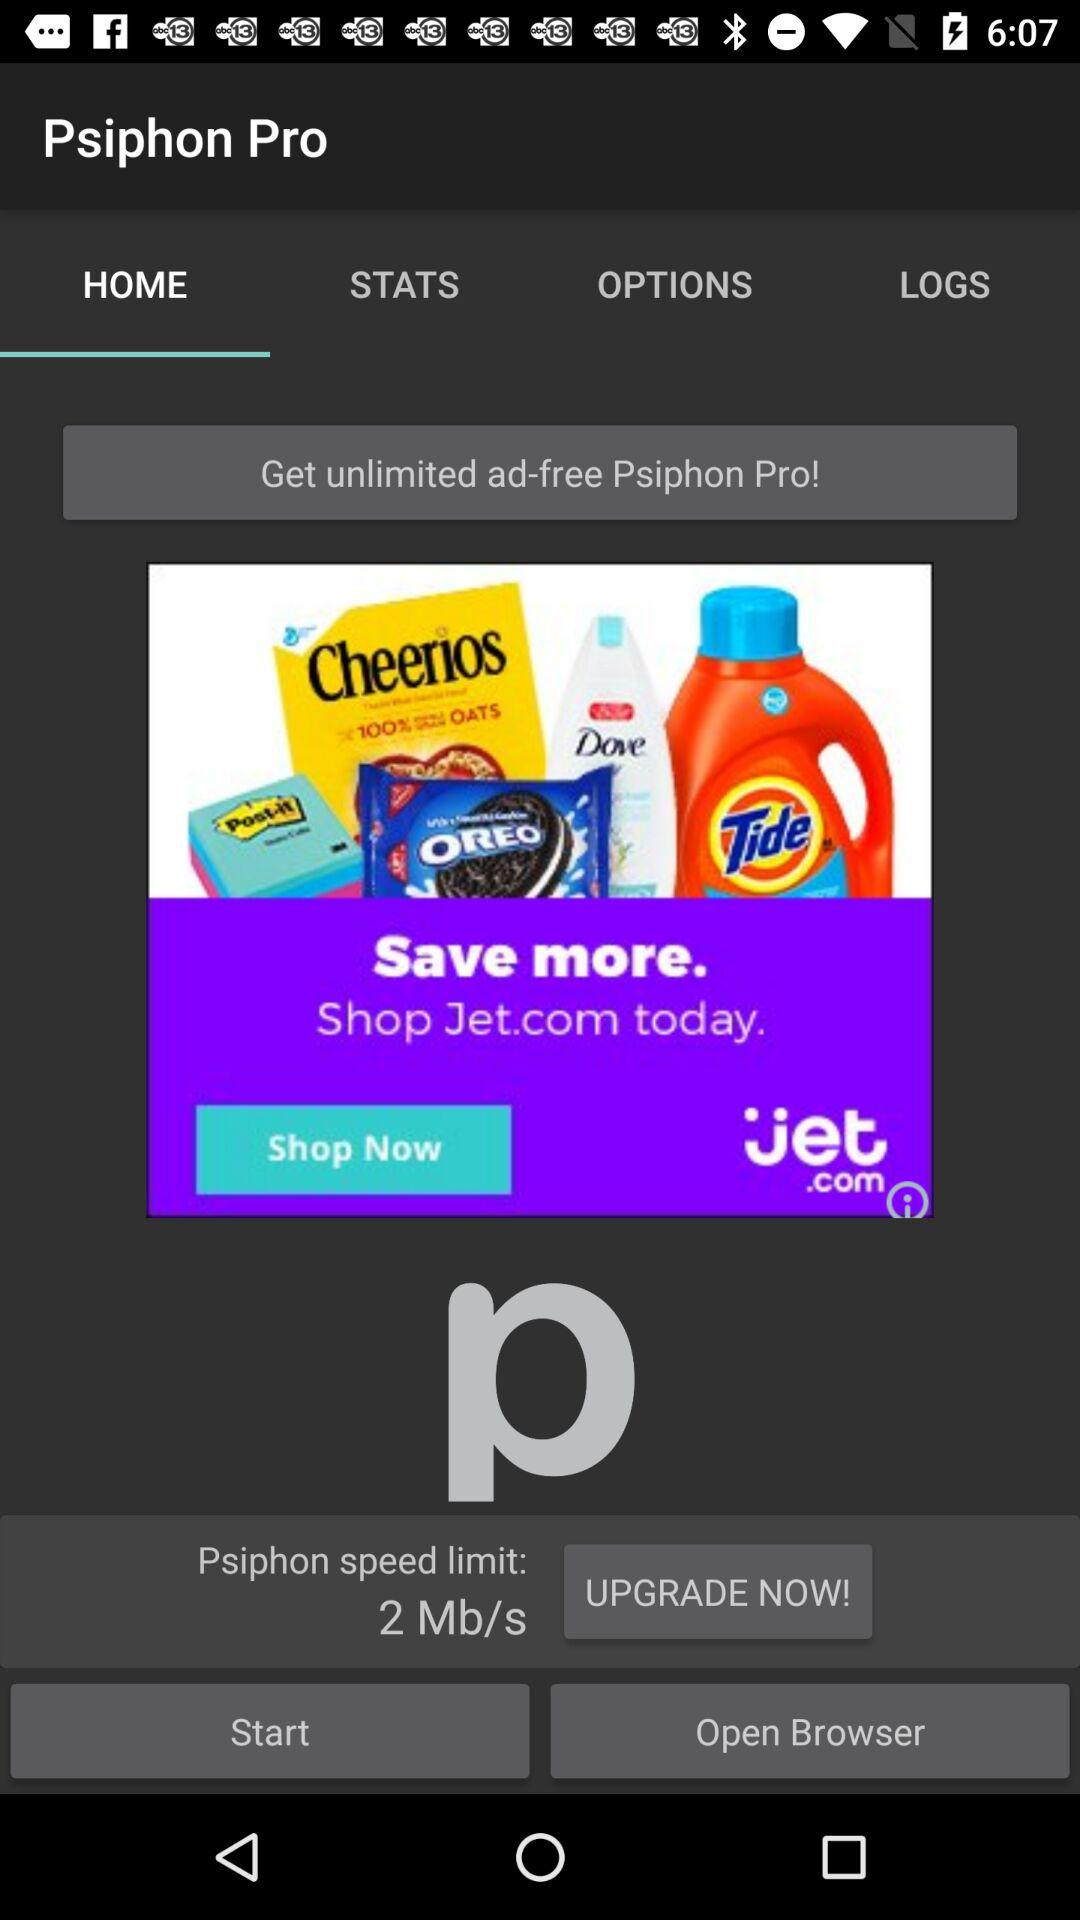Which tab is currently selected? The currently selected tab is "HOME". 